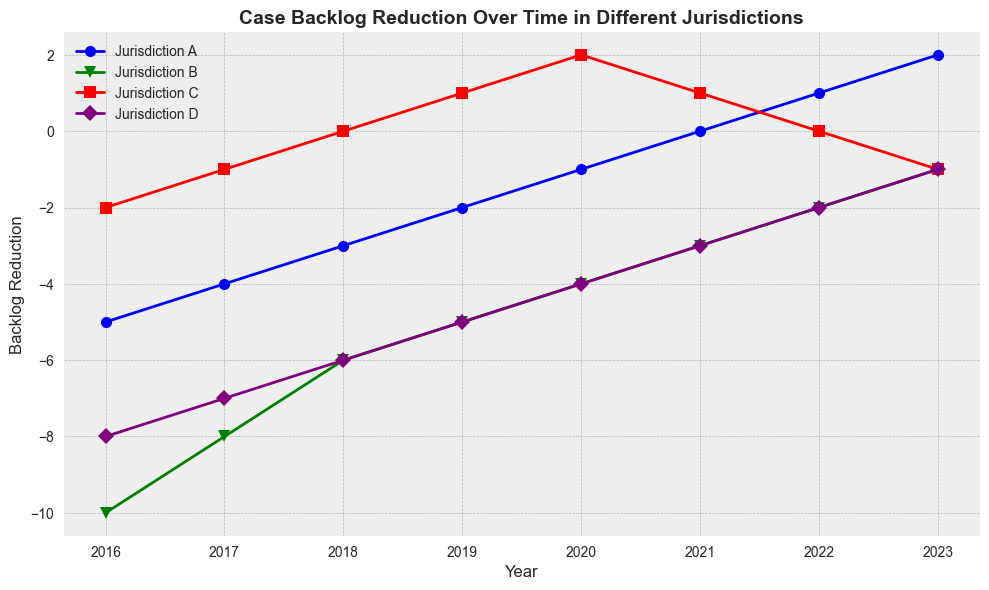What's the trend of backlog reduction in Jurisdiction A from 2016 to 2023? To determine the trend, observe the blue line representing Jurisdiction A. Starting from -5 in 2016, the values increase incrementally every year, reaching 2 in 2023. This indicates a consistent positive trend in backlog reduction.
Answer: Positive Which jurisdiction shows the least backlog reduction in 2016? Compare the endpoints of the lines at 2016. Jurisdiction B (green line) has a value of -10, which is the lowest among all jurisdictions for that year.
Answer: Jurisdiction B How many years did Jurisdiction C have positive backlog reduction values? To determine this, identify the positive values on the red line representing Jurisdiction C. Positive values occur in 2019 (1), 2020 (2), and 2021 (1), so three years in total.
Answer: 3 What is the difference in backlog reduction for Jurisdiction D between 2016 and 2023? Find the 2016 value for Jurisdiction D (purple line), which is -8, and the 2023 value, which is -1. The difference is calculated by (-1 - (-8)) = 7.
Answer: 7 Which jurisdiction shows a return to negative backlog reduction in 2023 after previously being positive? Observe the trends and identify that the red line (Jurisdiction C) transitions from positive in 2020, 2021, and 2019 back to negative in 2023 with a value of -1.
Answer: Jurisdiction C In which year did Jurisdiction B have a backlog reduction value of -3? The green line representing Jurisdiction B reaches the -3 value in 2021.
Answer: 2021 What is the combined backlog reduction value for all jurisdictions in 2020? Sum the values for 2020 across all jurisdictions: (-1 from A) + (-4 from B) + (2 from C) + (-4 from D). The sum is -1 - 4 + 2 - 4 = -7.
Answer: -7 Which jurisdiction has the most consistent positive improvement in backlog reduction over the years? Examine each line's trend. The blue line (Jurisdiction A) consistently increases by 1 every year, showing the most consistent positive improvement.
Answer: Jurisdiction A Among all years, in which year did Jurisdiction D reach the peak of backlog reduction? Identify the highest point on the purple line. Jurisdiction D's peak, the highest value (-1), occurs in 2023.
Answer: 2023 